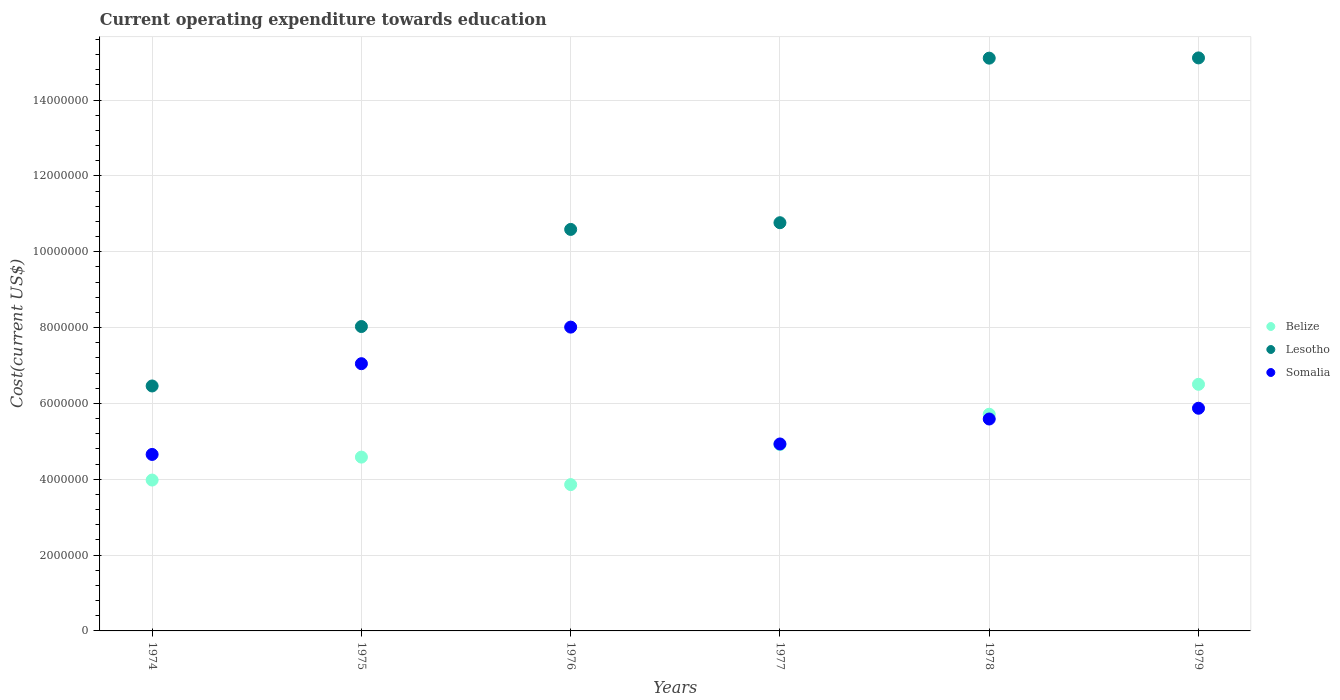What is the expenditure towards education in Somalia in 1977?
Your answer should be very brief. 4.93e+06. Across all years, what is the maximum expenditure towards education in Lesotho?
Your response must be concise. 1.51e+07. Across all years, what is the minimum expenditure towards education in Belize?
Give a very brief answer. 3.86e+06. In which year was the expenditure towards education in Belize maximum?
Provide a succinct answer. 1979. In which year was the expenditure towards education in Belize minimum?
Make the answer very short. 1976. What is the total expenditure towards education in Lesotho in the graph?
Offer a terse response. 6.61e+07. What is the difference between the expenditure towards education in Somalia in 1977 and that in 1978?
Give a very brief answer. -6.58e+05. What is the difference between the expenditure towards education in Lesotho in 1979 and the expenditure towards education in Somalia in 1975?
Your answer should be compact. 8.07e+06. What is the average expenditure towards education in Somalia per year?
Offer a very short reply. 6.02e+06. In the year 1975, what is the difference between the expenditure towards education in Lesotho and expenditure towards education in Belize?
Offer a terse response. 3.44e+06. In how many years, is the expenditure towards education in Lesotho greater than 5600000 US$?
Ensure brevity in your answer.  6. What is the ratio of the expenditure towards education in Belize in 1978 to that in 1979?
Offer a terse response. 0.88. Is the difference between the expenditure towards education in Lesotho in 1977 and 1979 greater than the difference between the expenditure towards education in Belize in 1977 and 1979?
Your answer should be very brief. No. What is the difference between the highest and the second highest expenditure towards education in Lesotho?
Offer a terse response. 6378.56. What is the difference between the highest and the lowest expenditure towards education in Somalia?
Keep it short and to the point. 3.36e+06. Is it the case that in every year, the sum of the expenditure towards education in Belize and expenditure towards education in Somalia  is greater than the expenditure towards education in Lesotho?
Your answer should be very brief. No. Is the expenditure towards education in Somalia strictly less than the expenditure towards education in Belize over the years?
Keep it short and to the point. No. How many dotlines are there?
Give a very brief answer. 3. What is the difference between two consecutive major ticks on the Y-axis?
Provide a succinct answer. 2.00e+06. Are the values on the major ticks of Y-axis written in scientific E-notation?
Ensure brevity in your answer.  No. Does the graph contain any zero values?
Make the answer very short. No. Where does the legend appear in the graph?
Keep it short and to the point. Center right. What is the title of the graph?
Keep it short and to the point. Current operating expenditure towards education. Does "Italy" appear as one of the legend labels in the graph?
Make the answer very short. No. What is the label or title of the X-axis?
Your response must be concise. Years. What is the label or title of the Y-axis?
Give a very brief answer. Cost(current US$). What is the Cost(current US$) of Belize in 1974?
Provide a succinct answer. 3.98e+06. What is the Cost(current US$) in Lesotho in 1974?
Offer a very short reply. 6.46e+06. What is the Cost(current US$) of Somalia in 1974?
Your answer should be very brief. 4.65e+06. What is the Cost(current US$) in Belize in 1975?
Make the answer very short. 4.58e+06. What is the Cost(current US$) in Lesotho in 1975?
Your answer should be compact. 8.03e+06. What is the Cost(current US$) in Somalia in 1975?
Give a very brief answer. 7.05e+06. What is the Cost(current US$) in Belize in 1976?
Provide a short and direct response. 3.86e+06. What is the Cost(current US$) in Lesotho in 1976?
Offer a very short reply. 1.06e+07. What is the Cost(current US$) of Somalia in 1976?
Make the answer very short. 8.01e+06. What is the Cost(current US$) in Belize in 1977?
Your answer should be very brief. 4.92e+06. What is the Cost(current US$) in Lesotho in 1977?
Your answer should be very brief. 1.08e+07. What is the Cost(current US$) in Somalia in 1977?
Keep it short and to the point. 4.93e+06. What is the Cost(current US$) of Belize in 1978?
Offer a terse response. 5.72e+06. What is the Cost(current US$) in Lesotho in 1978?
Your response must be concise. 1.51e+07. What is the Cost(current US$) in Somalia in 1978?
Ensure brevity in your answer.  5.59e+06. What is the Cost(current US$) of Belize in 1979?
Give a very brief answer. 6.50e+06. What is the Cost(current US$) of Lesotho in 1979?
Give a very brief answer. 1.51e+07. What is the Cost(current US$) of Somalia in 1979?
Offer a very short reply. 5.87e+06. Across all years, what is the maximum Cost(current US$) of Belize?
Give a very brief answer. 6.50e+06. Across all years, what is the maximum Cost(current US$) of Lesotho?
Give a very brief answer. 1.51e+07. Across all years, what is the maximum Cost(current US$) in Somalia?
Provide a succinct answer. 8.01e+06. Across all years, what is the minimum Cost(current US$) of Belize?
Ensure brevity in your answer.  3.86e+06. Across all years, what is the minimum Cost(current US$) of Lesotho?
Make the answer very short. 6.46e+06. Across all years, what is the minimum Cost(current US$) of Somalia?
Offer a very short reply. 4.65e+06. What is the total Cost(current US$) of Belize in the graph?
Give a very brief answer. 2.96e+07. What is the total Cost(current US$) in Lesotho in the graph?
Your response must be concise. 6.61e+07. What is the total Cost(current US$) in Somalia in the graph?
Your response must be concise. 3.61e+07. What is the difference between the Cost(current US$) of Belize in 1974 and that in 1975?
Provide a short and direct response. -6.05e+05. What is the difference between the Cost(current US$) of Lesotho in 1974 and that in 1975?
Ensure brevity in your answer.  -1.57e+06. What is the difference between the Cost(current US$) of Somalia in 1974 and that in 1975?
Your answer should be compact. -2.39e+06. What is the difference between the Cost(current US$) in Belize in 1974 and that in 1976?
Provide a short and direct response. 1.20e+05. What is the difference between the Cost(current US$) of Lesotho in 1974 and that in 1976?
Your answer should be very brief. -4.13e+06. What is the difference between the Cost(current US$) in Somalia in 1974 and that in 1976?
Offer a very short reply. -3.36e+06. What is the difference between the Cost(current US$) in Belize in 1974 and that in 1977?
Keep it short and to the point. -9.36e+05. What is the difference between the Cost(current US$) of Lesotho in 1974 and that in 1977?
Give a very brief answer. -4.31e+06. What is the difference between the Cost(current US$) of Somalia in 1974 and that in 1977?
Ensure brevity in your answer.  -2.76e+05. What is the difference between the Cost(current US$) of Belize in 1974 and that in 1978?
Offer a terse response. -1.74e+06. What is the difference between the Cost(current US$) of Lesotho in 1974 and that in 1978?
Your answer should be very brief. -8.65e+06. What is the difference between the Cost(current US$) in Somalia in 1974 and that in 1978?
Your answer should be very brief. -9.35e+05. What is the difference between the Cost(current US$) in Belize in 1974 and that in 1979?
Make the answer very short. -2.53e+06. What is the difference between the Cost(current US$) of Lesotho in 1974 and that in 1979?
Your answer should be very brief. -8.65e+06. What is the difference between the Cost(current US$) of Somalia in 1974 and that in 1979?
Your response must be concise. -1.22e+06. What is the difference between the Cost(current US$) of Belize in 1975 and that in 1976?
Your answer should be compact. 7.25e+05. What is the difference between the Cost(current US$) of Lesotho in 1975 and that in 1976?
Make the answer very short. -2.56e+06. What is the difference between the Cost(current US$) of Somalia in 1975 and that in 1976?
Make the answer very short. -9.65e+05. What is the difference between the Cost(current US$) in Belize in 1975 and that in 1977?
Give a very brief answer. -3.31e+05. What is the difference between the Cost(current US$) in Lesotho in 1975 and that in 1977?
Give a very brief answer. -2.74e+06. What is the difference between the Cost(current US$) in Somalia in 1975 and that in 1977?
Offer a very short reply. 2.12e+06. What is the difference between the Cost(current US$) in Belize in 1975 and that in 1978?
Keep it short and to the point. -1.13e+06. What is the difference between the Cost(current US$) of Lesotho in 1975 and that in 1978?
Make the answer very short. -7.08e+06. What is the difference between the Cost(current US$) of Somalia in 1975 and that in 1978?
Provide a short and direct response. 1.46e+06. What is the difference between the Cost(current US$) in Belize in 1975 and that in 1979?
Keep it short and to the point. -1.92e+06. What is the difference between the Cost(current US$) of Lesotho in 1975 and that in 1979?
Provide a short and direct response. -7.09e+06. What is the difference between the Cost(current US$) of Somalia in 1975 and that in 1979?
Provide a succinct answer. 1.18e+06. What is the difference between the Cost(current US$) of Belize in 1976 and that in 1977?
Keep it short and to the point. -1.06e+06. What is the difference between the Cost(current US$) of Lesotho in 1976 and that in 1977?
Your response must be concise. -1.77e+05. What is the difference between the Cost(current US$) in Somalia in 1976 and that in 1977?
Give a very brief answer. 3.08e+06. What is the difference between the Cost(current US$) of Belize in 1976 and that in 1978?
Provide a succinct answer. -1.86e+06. What is the difference between the Cost(current US$) in Lesotho in 1976 and that in 1978?
Your response must be concise. -4.52e+06. What is the difference between the Cost(current US$) in Somalia in 1976 and that in 1978?
Your response must be concise. 2.42e+06. What is the difference between the Cost(current US$) of Belize in 1976 and that in 1979?
Your answer should be compact. -2.65e+06. What is the difference between the Cost(current US$) of Lesotho in 1976 and that in 1979?
Make the answer very short. -4.52e+06. What is the difference between the Cost(current US$) in Somalia in 1976 and that in 1979?
Keep it short and to the point. 2.14e+06. What is the difference between the Cost(current US$) of Belize in 1977 and that in 1978?
Make the answer very short. -8.00e+05. What is the difference between the Cost(current US$) in Lesotho in 1977 and that in 1978?
Your answer should be compact. -4.34e+06. What is the difference between the Cost(current US$) in Somalia in 1977 and that in 1978?
Your answer should be very brief. -6.58e+05. What is the difference between the Cost(current US$) of Belize in 1977 and that in 1979?
Make the answer very short. -1.59e+06. What is the difference between the Cost(current US$) of Lesotho in 1977 and that in 1979?
Provide a succinct answer. -4.35e+06. What is the difference between the Cost(current US$) in Somalia in 1977 and that in 1979?
Provide a short and direct response. -9.42e+05. What is the difference between the Cost(current US$) in Belize in 1978 and that in 1979?
Ensure brevity in your answer.  -7.89e+05. What is the difference between the Cost(current US$) in Lesotho in 1978 and that in 1979?
Offer a terse response. -6378.56. What is the difference between the Cost(current US$) in Somalia in 1978 and that in 1979?
Your answer should be compact. -2.84e+05. What is the difference between the Cost(current US$) of Belize in 1974 and the Cost(current US$) of Lesotho in 1975?
Your answer should be compact. -4.05e+06. What is the difference between the Cost(current US$) in Belize in 1974 and the Cost(current US$) in Somalia in 1975?
Your answer should be very brief. -3.07e+06. What is the difference between the Cost(current US$) of Lesotho in 1974 and the Cost(current US$) of Somalia in 1975?
Provide a short and direct response. -5.88e+05. What is the difference between the Cost(current US$) in Belize in 1974 and the Cost(current US$) in Lesotho in 1976?
Give a very brief answer. -6.61e+06. What is the difference between the Cost(current US$) in Belize in 1974 and the Cost(current US$) in Somalia in 1976?
Ensure brevity in your answer.  -4.03e+06. What is the difference between the Cost(current US$) of Lesotho in 1974 and the Cost(current US$) of Somalia in 1976?
Provide a short and direct response. -1.55e+06. What is the difference between the Cost(current US$) of Belize in 1974 and the Cost(current US$) of Lesotho in 1977?
Your answer should be compact. -6.79e+06. What is the difference between the Cost(current US$) of Belize in 1974 and the Cost(current US$) of Somalia in 1977?
Your response must be concise. -9.52e+05. What is the difference between the Cost(current US$) in Lesotho in 1974 and the Cost(current US$) in Somalia in 1977?
Make the answer very short. 1.53e+06. What is the difference between the Cost(current US$) in Belize in 1974 and the Cost(current US$) in Lesotho in 1978?
Your answer should be very brief. -1.11e+07. What is the difference between the Cost(current US$) of Belize in 1974 and the Cost(current US$) of Somalia in 1978?
Ensure brevity in your answer.  -1.61e+06. What is the difference between the Cost(current US$) in Lesotho in 1974 and the Cost(current US$) in Somalia in 1978?
Your response must be concise. 8.71e+05. What is the difference between the Cost(current US$) in Belize in 1974 and the Cost(current US$) in Lesotho in 1979?
Offer a very short reply. -1.11e+07. What is the difference between the Cost(current US$) of Belize in 1974 and the Cost(current US$) of Somalia in 1979?
Offer a terse response. -1.89e+06. What is the difference between the Cost(current US$) in Lesotho in 1974 and the Cost(current US$) in Somalia in 1979?
Your response must be concise. 5.88e+05. What is the difference between the Cost(current US$) in Belize in 1975 and the Cost(current US$) in Lesotho in 1976?
Provide a succinct answer. -6.01e+06. What is the difference between the Cost(current US$) of Belize in 1975 and the Cost(current US$) of Somalia in 1976?
Keep it short and to the point. -3.43e+06. What is the difference between the Cost(current US$) of Lesotho in 1975 and the Cost(current US$) of Somalia in 1976?
Make the answer very short. 1.53e+04. What is the difference between the Cost(current US$) of Belize in 1975 and the Cost(current US$) of Lesotho in 1977?
Ensure brevity in your answer.  -6.18e+06. What is the difference between the Cost(current US$) in Belize in 1975 and the Cost(current US$) in Somalia in 1977?
Provide a succinct answer. -3.47e+05. What is the difference between the Cost(current US$) of Lesotho in 1975 and the Cost(current US$) of Somalia in 1977?
Offer a very short reply. 3.10e+06. What is the difference between the Cost(current US$) in Belize in 1975 and the Cost(current US$) in Lesotho in 1978?
Keep it short and to the point. -1.05e+07. What is the difference between the Cost(current US$) of Belize in 1975 and the Cost(current US$) of Somalia in 1978?
Make the answer very short. -1.00e+06. What is the difference between the Cost(current US$) in Lesotho in 1975 and the Cost(current US$) in Somalia in 1978?
Your response must be concise. 2.44e+06. What is the difference between the Cost(current US$) of Belize in 1975 and the Cost(current US$) of Lesotho in 1979?
Offer a terse response. -1.05e+07. What is the difference between the Cost(current US$) of Belize in 1975 and the Cost(current US$) of Somalia in 1979?
Your answer should be compact. -1.29e+06. What is the difference between the Cost(current US$) in Lesotho in 1975 and the Cost(current US$) in Somalia in 1979?
Your answer should be compact. 2.16e+06. What is the difference between the Cost(current US$) in Belize in 1976 and the Cost(current US$) in Lesotho in 1977?
Make the answer very short. -6.91e+06. What is the difference between the Cost(current US$) of Belize in 1976 and the Cost(current US$) of Somalia in 1977?
Give a very brief answer. -1.07e+06. What is the difference between the Cost(current US$) of Lesotho in 1976 and the Cost(current US$) of Somalia in 1977?
Keep it short and to the point. 5.66e+06. What is the difference between the Cost(current US$) in Belize in 1976 and the Cost(current US$) in Lesotho in 1978?
Your response must be concise. -1.12e+07. What is the difference between the Cost(current US$) of Belize in 1976 and the Cost(current US$) of Somalia in 1978?
Provide a short and direct response. -1.73e+06. What is the difference between the Cost(current US$) in Lesotho in 1976 and the Cost(current US$) in Somalia in 1978?
Your answer should be compact. 5.00e+06. What is the difference between the Cost(current US$) in Belize in 1976 and the Cost(current US$) in Lesotho in 1979?
Provide a succinct answer. -1.13e+07. What is the difference between the Cost(current US$) of Belize in 1976 and the Cost(current US$) of Somalia in 1979?
Offer a very short reply. -2.01e+06. What is the difference between the Cost(current US$) in Lesotho in 1976 and the Cost(current US$) in Somalia in 1979?
Make the answer very short. 4.72e+06. What is the difference between the Cost(current US$) of Belize in 1977 and the Cost(current US$) of Lesotho in 1978?
Give a very brief answer. -1.02e+07. What is the difference between the Cost(current US$) in Belize in 1977 and the Cost(current US$) in Somalia in 1978?
Offer a very short reply. -6.74e+05. What is the difference between the Cost(current US$) in Lesotho in 1977 and the Cost(current US$) in Somalia in 1978?
Your response must be concise. 5.18e+06. What is the difference between the Cost(current US$) in Belize in 1977 and the Cost(current US$) in Lesotho in 1979?
Your answer should be compact. -1.02e+07. What is the difference between the Cost(current US$) of Belize in 1977 and the Cost(current US$) of Somalia in 1979?
Offer a terse response. -9.58e+05. What is the difference between the Cost(current US$) in Lesotho in 1977 and the Cost(current US$) in Somalia in 1979?
Give a very brief answer. 4.89e+06. What is the difference between the Cost(current US$) of Belize in 1978 and the Cost(current US$) of Lesotho in 1979?
Give a very brief answer. -9.40e+06. What is the difference between the Cost(current US$) of Belize in 1978 and the Cost(current US$) of Somalia in 1979?
Offer a very short reply. -1.58e+05. What is the difference between the Cost(current US$) of Lesotho in 1978 and the Cost(current US$) of Somalia in 1979?
Give a very brief answer. 9.23e+06. What is the average Cost(current US$) of Belize per year?
Provide a short and direct response. 4.93e+06. What is the average Cost(current US$) of Lesotho per year?
Offer a terse response. 1.10e+07. What is the average Cost(current US$) in Somalia per year?
Provide a succinct answer. 6.02e+06. In the year 1974, what is the difference between the Cost(current US$) of Belize and Cost(current US$) of Lesotho?
Offer a very short reply. -2.48e+06. In the year 1974, what is the difference between the Cost(current US$) of Belize and Cost(current US$) of Somalia?
Offer a terse response. -6.76e+05. In the year 1974, what is the difference between the Cost(current US$) of Lesotho and Cost(current US$) of Somalia?
Make the answer very short. 1.81e+06. In the year 1975, what is the difference between the Cost(current US$) of Belize and Cost(current US$) of Lesotho?
Your answer should be compact. -3.44e+06. In the year 1975, what is the difference between the Cost(current US$) in Belize and Cost(current US$) in Somalia?
Offer a terse response. -2.46e+06. In the year 1975, what is the difference between the Cost(current US$) in Lesotho and Cost(current US$) in Somalia?
Provide a short and direct response. 9.80e+05. In the year 1976, what is the difference between the Cost(current US$) of Belize and Cost(current US$) of Lesotho?
Offer a very short reply. -6.73e+06. In the year 1976, what is the difference between the Cost(current US$) of Belize and Cost(current US$) of Somalia?
Your response must be concise. -4.15e+06. In the year 1976, what is the difference between the Cost(current US$) in Lesotho and Cost(current US$) in Somalia?
Keep it short and to the point. 2.58e+06. In the year 1977, what is the difference between the Cost(current US$) of Belize and Cost(current US$) of Lesotho?
Your response must be concise. -5.85e+06. In the year 1977, what is the difference between the Cost(current US$) in Belize and Cost(current US$) in Somalia?
Provide a succinct answer. -1.60e+04. In the year 1977, what is the difference between the Cost(current US$) in Lesotho and Cost(current US$) in Somalia?
Your answer should be very brief. 5.84e+06. In the year 1978, what is the difference between the Cost(current US$) in Belize and Cost(current US$) in Lesotho?
Make the answer very short. -9.39e+06. In the year 1978, what is the difference between the Cost(current US$) in Belize and Cost(current US$) in Somalia?
Offer a very short reply. 1.26e+05. In the year 1978, what is the difference between the Cost(current US$) in Lesotho and Cost(current US$) in Somalia?
Provide a short and direct response. 9.52e+06. In the year 1979, what is the difference between the Cost(current US$) in Belize and Cost(current US$) in Lesotho?
Your answer should be compact. -8.61e+06. In the year 1979, what is the difference between the Cost(current US$) in Belize and Cost(current US$) in Somalia?
Ensure brevity in your answer.  6.31e+05. In the year 1979, what is the difference between the Cost(current US$) in Lesotho and Cost(current US$) in Somalia?
Ensure brevity in your answer.  9.24e+06. What is the ratio of the Cost(current US$) in Belize in 1974 to that in 1975?
Offer a very short reply. 0.87. What is the ratio of the Cost(current US$) in Lesotho in 1974 to that in 1975?
Provide a succinct answer. 0.8. What is the ratio of the Cost(current US$) in Somalia in 1974 to that in 1975?
Your response must be concise. 0.66. What is the ratio of the Cost(current US$) of Belize in 1974 to that in 1976?
Offer a very short reply. 1.03. What is the ratio of the Cost(current US$) in Lesotho in 1974 to that in 1976?
Give a very brief answer. 0.61. What is the ratio of the Cost(current US$) in Somalia in 1974 to that in 1976?
Provide a succinct answer. 0.58. What is the ratio of the Cost(current US$) in Belize in 1974 to that in 1977?
Provide a succinct answer. 0.81. What is the ratio of the Cost(current US$) in Lesotho in 1974 to that in 1977?
Give a very brief answer. 0.6. What is the ratio of the Cost(current US$) of Somalia in 1974 to that in 1977?
Your answer should be compact. 0.94. What is the ratio of the Cost(current US$) in Belize in 1974 to that in 1978?
Ensure brevity in your answer.  0.7. What is the ratio of the Cost(current US$) of Lesotho in 1974 to that in 1978?
Your response must be concise. 0.43. What is the ratio of the Cost(current US$) in Somalia in 1974 to that in 1978?
Make the answer very short. 0.83. What is the ratio of the Cost(current US$) in Belize in 1974 to that in 1979?
Keep it short and to the point. 0.61. What is the ratio of the Cost(current US$) in Lesotho in 1974 to that in 1979?
Provide a short and direct response. 0.43. What is the ratio of the Cost(current US$) in Somalia in 1974 to that in 1979?
Your answer should be very brief. 0.79. What is the ratio of the Cost(current US$) of Belize in 1975 to that in 1976?
Keep it short and to the point. 1.19. What is the ratio of the Cost(current US$) of Lesotho in 1975 to that in 1976?
Offer a terse response. 0.76. What is the ratio of the Cost(current US$) of Somalia in 1975 to that in 1976?
Your answer should be compact. 0.88. What is the ratio of the Cost(current US$) in Belize in 1975 to that in 1977?
Make the answer very short. 0.93. What is the ratio of the Cost(current US$) in Lesotho in 1975 to that in 1977?
Provide a short and direct response. 0.75. What is the ratio of the Cost(current US$) of Somalia in 1975 to that in 1977?
Ensure brevity in your answer.  1.43. What is the ratio of the Cost(current US$) of Belize in 1975 to that in 1978?
Your answer should be compact. 0.8. What is the ratio of the Cost(current US$) in Lesotho in 1975 to that in 1978?
Make the answer very short. 0.53. What is the ratio of the Cost(current US$) in Somalia in 1975 to that in 1978?
Offer a very short reply. 1.26. What is the ratio of the Cost(current US$) in Belize in 1975 to that in 1979?
Ensure brevity in your answer.  0.7. What is the ratio of the Cost(current US$) in Lesotho in 1975 to that in 1979?
Your answer should be compact. 0.53. What is the ratio of the Cost(current US$) in Somalia in 1975 to that in 1979?
Make the answer very short. 1.2. What is the ratio of the Cost(current US$) in Belize in 1976 to that in 1977?
Give a very brief answer. 0.79. What is the ratio of the Cost(current US$) in Lesotho in 1976 to that in 1977?
Your answer should be very brief. 0.98. What is the ratio of the Cost(current US$) in Somalia in 1976 to that in 1977?
Offer a terse response. 1.62. What is the ratio of the Cost(current US$) in Belize in 1976 to that in 1978?
Provide a succinct answer. 0.68. What is the ratio of the Cost(current US$) in Lesotho in 1976 to that in 1978?
Keep it short and to the point. 0.7. What is the ratio of the Cost(current US$) in Somalia in 1976 to that in 1978?
Your response must be concise. 1.43. What is the ratio of the Cost(current US$) in Belize in 1976 to that in 1979?
Make the answer very short. 0.59. What is the ratio of the Cost(current US$) in Lesotho in 1976 to that in 1979?
Provide a succinct answer. 0.7. What is the ratio of the Cost(current US$) in Somalia in 1976 to that in 1979?
Make the answer very short. 1.36. What is the ratio of the Cost(current US$) in Belize in 1977 to that in 1978?
Your answer should be very brief. 0.86. What is the ratio of the Cost(current US$) in Lesotho in 1977 to that in 1978?
Make the answer very short. 0.71. What is the ratio of the Cost(current US$) in Somalia in 1977 to that in 1978?
Give a very brief answer. 0.88. What is the ratio of the Cost(current US$) of Belize in 1977 to that in 1979?
Keep it short and to the point. 0.76. What is the ratio of the Cost(current US$) of Lesotho in 1977 to that in 1979?
Keep it short and to the point. 0.71. What is the ratio of the Cost(current US$) in Somalia in 1977 to that in 1979?
Offer a very short reply. 0.84. What is the ratio of the Cost(current US$) of Belize in 1978 to that in 1979?
Keep it short and to the point. 0.88. What is the ratio of the Cost(current US$) of Somalia in 1978 to that in 1979?
Your answer should be very brief. 0.95. What is the difference between the highest and the second highest Cost(current US$) in Belize?
Offer a very short reply. 7.89e+05. What is the difference between the highest and the second highest Cost(current US$) in Lesotho?
Your answer should be very brief. 6378.56. What is the difference between the highest and the second highest Cost(current US$) of Somalia?
Provide a short and direct response. 9.65e+05. What is the difference between the highest and the lowest Cost(current US$) in Belize?
Your answer should be compact. 2.65e+06. What is the difference between the highest and the lowest Cost(current US$) of Lesotho?
Give a very brief answer. 8.65e+06. What is the difference between the highest and the lowest Cost(current US$) of Somalia?
Offer a very short reply. 3.36e+06. 